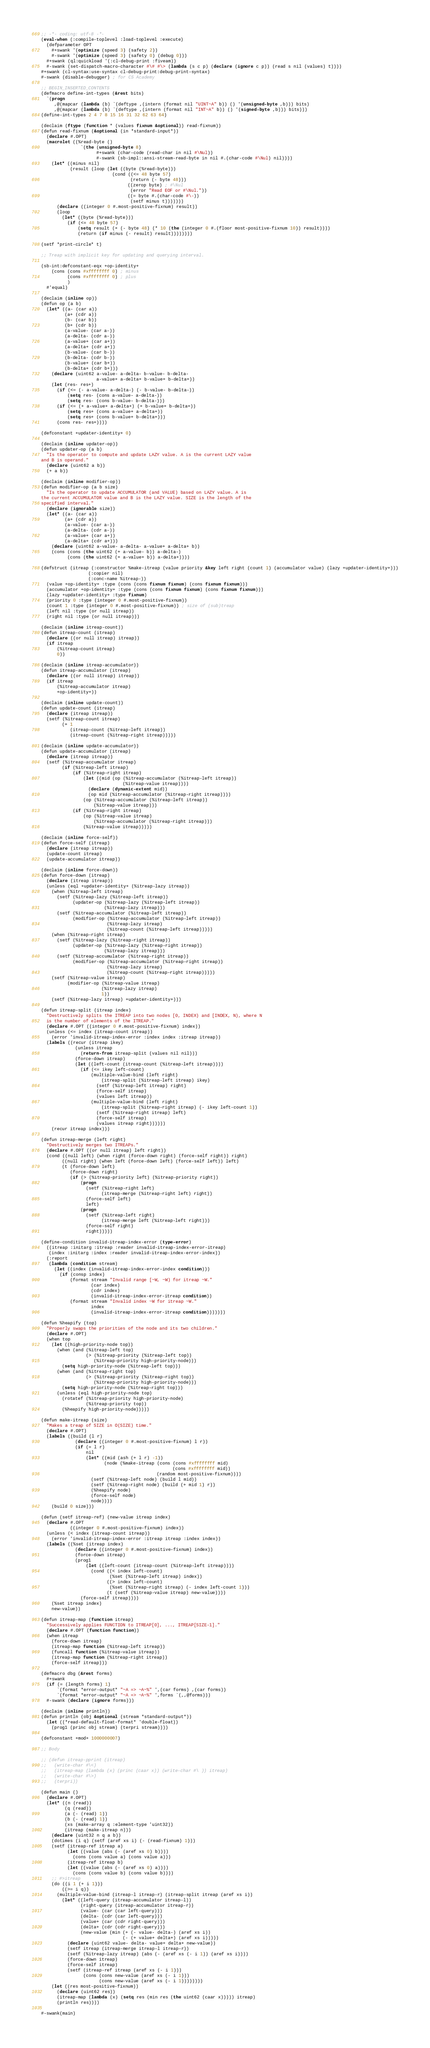Convert code to text. <code><loc_0><loc_0><loc_500><loc_500><_Lisp_>;; -*- coding: utf-8 -*-
(eval-when (:compile-toplevel :load-toplevel :execute)
  (defparameter OPT
    #+swank '(optimize (speed 3) (safety 2))
    #-swank '(optimize (speed 3) (safety 0) (debug 0)))
  #+swank (ql:quickload '(:cl-debug-print :fiveam))
  #-swank (set-dispatch-macro-character #\# #\> (lambda (s c p) (declare (ignore c p)) (read s nil (values) t))))
#+swank (cl-syntax:use-syntax cl-debug-print:debug-print-syntax)
#-swank (disable-debugger) ; for CS Academy

;; BEGIN_INSERTED_CONTENTS
(defmacro define-int-types (&rest bits)
  `(progn
     ,@(mapcar (lambda (b) `(deftype ,(intern (format nil "UINT~A" b)) () '(unsigned-byte ,b))) bits)
     ,@(mapcar (lambda (b) `(deftype ,(intern (format nil "INT~A" b)) () '(signed-byte ,b))) bits)))
(define-int-types 2 4 7 8 15 16 31 32 62 63 64)

(declaim (ftype (function * (values fixnum &optional)) read-fixnum))
(defun read-fixnum (&optional (in *standard-input*))
  (declare #.OPT)
  (macrolet ((%read-byte ()
               `(the (unsigned-byte 8)
                     #+swank (char-code (read-char in nil #\Nul))
                     #-swank (sb-impl::ansi-stream-read-byte in nil #.(char-code #\Nul) nil))))
    (let* ((minus nil)
           (result (loop (let ((byte (%read-byte)))
                           (cond ((<= 48 byte 57)
                                  (return (- byte 48)))
                                 ((zerop byte) ; #\Nul
                                  (error "Read EOF or #\Nul."))
                                 ((= byte #.(char-code #\-))
                                  (setf minus t)))))))
      (declare ((integer 0 #.most-positive-fixnum) result))
      (loop
        (let* ((byte (%read-byte)))
          (if (<= 48 byte 57)
              (setq result (+ (- byte 48) (* 10 (the (integer 0 #.(floor most-positive-fixnum 10)) result))))
              (return (if minus (- result) result))))))))

(setf *print-circle* t)

;; Treap with implicit key for updating and querying interval.

(sb-int:defconstant-eqx +op-identity+
    (cons (cons #xffffffff 0) ; minus
          (cons #xffffffff 0) ; plus
          )
  #'equal)

(declaim (inline op))
(defun op (a b)
  (let* ((a- (car a))
         (a+ (cdr a))
         (b- (car b))
         (b+ (cdr b))
         (a-value- (car a-))
         (a-delta- (cdr a-))
         (a-value+ (car a+))
         (a-delta+ (cdr a+))
         (b-value- (car b-))
         (b-delta- (cdr b-))
         (b-value+ (car b+))
         (b-delta+ (cdr b+)))
    (declare (uint62 a-value- a-delta- b-value- b-delta-
                     a-value+ a-delta+ b-value+ b-delta+))
    (let (res- res+)
      (if (<= (- a-value- a-delta-) (- b-value- b-delta-))
          (setq res- (cons a-value- a-delta-))
          (setq res- (cons b-value- b-delta-)))
      (if (<= (+ a-value+ a-delta+) (+ b-value+ b-delta+))
          (setq res+ (cons a-value+ a-delta+))
          (setq res+ (cons b-value+ b-delta+)))
      (cons res- res+))))

(defconstant +updater-identity+ 0)

(declaim (inline updater-op))
(defun updater-op (a b)
  "Is the operator to compute and update LAZY value. A is the current LAZY value
and B is operand."
  (declare (uint62 a b))
  (+ a b))

(declaim (inline modifier-op))
(defun modifier-op (a b size)
  "Is the operator to update ACCUMULATOR (and VALUE) based on LAZY value. A is
the current ACCUMULATOR value and B is the LAZY value. SIZE is the length of the
specified interval."
  (declare (ignorable size))
  (let* ((a- (car a))
         (a+ (cdr a))
         (a-value- (car a-))
         (a-delta- (cdr a-))
         (a-value+ (car a+))
         (a-delta+ (cdr a+)))
    (declare (uint62 a-value- a-delta- a-value+ a-delta+ b))
    (cons (cons (the uint62 (+ a-value- b)) a-delta-)
          (cons (the uint62 (+ a-value+ b)) a-delta+))))

(defstruct (itreap (:constructor %make-itreap (value priority &key left right (count 1) (accumulator value) (lazy +updater-identity+)))
                  (:copier nil)
                  (:conc-name %itreap-))
  (value +op-identity+ :type (cons (cons fixnum fixnum) (cons fixnum fixnum)))
  (accumulator +op-identity+ :type (cons (cons fixnum fixnum) (cons fixnum fixnum)))
  (lazy +updater-identity+ :type fixnum)
  (priority 0 :type (integer 0 #.most-positive-fixnum))
  (count 1 :type (integer 0 #.most-positive-fixnum)) ; size of (sub)treap
  (left nil :type (or null itreap))
  (right nil :type (or null itreap)))

(declaim (inline itreap-count))
(defun itreap-count (itreap)
  (declare ((or null itreap) itreap))
  (if itreap
      (%itreap-count itreap)
      0))

(declaim (inline itreap-accumulator))
(defun itreap-accumulator (itreap)
  (declare ((or null itreap) itreap))
  (if itreap
      (%itreap-accumulator itreap)
      +op-identity+))

(declaim (inline update-count))
(defun update-count (itreap)
  (declare (itreap itreap))
  (setf (%itreap-count itreap)
        (+ 1
           (itreap-count (%itreap-left itreap))
           (itreap-count (%itreap-right itreap)))))

(declaim (inline update-accumulator))
(defun update-accumulator (itreap)
  (declare (itreap itreap))
  (setf (%itreap-accumulator itreap)
        (if (%itreap-left itreap)
            (if (%itreap-right itreap)
                (let ((mid (op (%itreap-accumulator (%itreap-left itreap))
                               (%itreap-value itreap))))
                  (declare (dynamic-extent mid))
                  (op mid (%itreap-accumulator (%itreap-right itreap))))
                (op (%itreap-accumulator (%itreap-left itreap))
                    (%itreap-value itreap)))
            (if (%itreap-right itreap)
                (op (%itreap-value itreap)
                    (%itreap-accumulator (%itreap-right itreap)))
                (%itreap-value itreap)))))

(declaim (inline force-self))
(defun force-self (itreap)
  (declare (itreap itreap))
  (update-count itreap)
  (update-accumulator itreap))

(declaim (inline force-down))
(defun force-down (itreap)
  (declare (itreap itreap))
  (unless (eql +updater-identity+ (%itreap-lazy itreap))
    (when (%itreap-left itreap)
      (setf (%itreap-lazy (%itreap-left itreap))
            (updater-op (%itreap-lazy (%itreap-left itreap))
                        (%itreap-lazy itreap)))
      (setf (%itreap-accumulator (%itreap-left itreap))
            (modifier-op (%itreap-accumulator (%itreap-left itreap))
                         (%itreap-lazy itreap)
                         (%itreap-count (%itreap-left itreap)))))
    (when (%itreap-right itreap)
      (setf (%itreap-lazy (%itreap-right itreap))
            (updater-op (%itreap-lazy (%itreap-right itreap))
                        (%itreap-lazy itreap)))
      (setf (%itreap-accumulator (%itreap-right itreap))
            (modifier-op (%itreap-accumulator (%itreap-right itreap))
                         (%itreap-lazy itreap)
                         (%itreap-count (%itreap-right itreap)))))
    (setf (%itreap-value itreap)
          (modifier-op (%itreap-value itreap)
                       (%itreap-lazy itreap)
                       1))
    (setf (%itreap-lazy itreap) +updater-identity+)))

(defun itreap-split (itreap index)
  "Destructively splits the ITREAP into two nodes [0, INDEX) and [INDEX, N), where N
  is the number of elements of the ITREAP."
  (declare #.OPT ((integer 0 #.most-positive-fixnum) index))
  (unless (<= index (itreap-count itreap))
    (error 'invalid-itreap-index-error :index index :itreap itreap))
  (labels ((recur (itreap ikey)
             (unless itreap
               (return-from itreap-split (values nil nil)))
             (force-down itreap)
             (let ((left-count (itreap-count (%itreap-left itreap))))
               (if (<= ikey left-count)
                   (multiple-value-bind (left right)
                       (itreap-split (%itreap-left itreap) ikey)
                     (setf (%itreap-left itreap) right)
                     (force-self itreap)
                     (values left itreap))
                   (multiple-value-bind (left right)
                       (itreap-split (%itreap-right itreap) (- ikey left-count 1))
                     (setf (%itreap-right itreap) left)
                     (force-self itreap)
                     (values itreap right))))))
    (recur itreap index)))

(defun itreap-merge (left right)
  "Destructively merges two ITREAPs."
  (declare #.OPT ((or null itreap) left right))
  (cond ((null left) (when right (force-down right) (force-self right)) right)
        ((null right) (when left (force-down left) (force-self left)) left)
        (t (force-down left)
           (force-down right)
           (if (> (%itreap-priority left) (%itreap-priority right))
               (progn
                 (setf (%itreap-right left)
                       (itreap-merge (%itreap-right left) right))
                 (force-self left)
                 left)
               (progn
                 (setf (%itreap-left right)
                       (itreap-merge left (%itreap-left right)))
                 (force-self right)
                 right)))))

(define-condition invalid-itreap-index-error (type-error)
  ((itreap :initarg :itreap :reader invalid-itreap-index-error-itreap)
   (index :initarg :index :reader invalid-itreap-index-error-index))
  (:report
   (lambda (condition stream)
     (let ((index (invalid-itreap-index-error-index condition)))
       (if (consp index)
           (format stream "Invalid range [~W, ~W) for itreap ~W."
                   (car index)
                   (cdr index)
                   (invalid-itreap-index-error-itreap condition))
           (format stream "Invalid index ~W for itreap ~W."
                   index
                   (invalid-itreap-index-error-itreap condition)))))))

(defun %heapify (top)
  "Properly swaps the priorities of the node and its two children."
  (declare #.OPT)
  (when top
    (let ((high-priority-node top))
      (when (and (%itreap-left top)
                 (> (%itreap-priority (%itreap-left top))
                    (%itreap-priority high-priority-node)))
        (setq high-priority-node (%itreap-left top)))
      (when (and (%itreap-right top)
                 (> (%itreap-priority (%itreap-right top))
                    (%itreap-priority high-priority-node)))
        (setq high-priority-node (%itreap-right top)))
      (unless (eql high-priority-node top)
        (rotatef (%itreap-priority high-priority-node)
                 (%itreap-priority top))
        (%heapify high-priority-node)))))

(defun make-itreap (size)
  "Makes a treap of SIZE in O(SIZE) time."
  (declare #.OPT)
  (labels ((build (l r)
             (declare ((integer 0 #.most-positive-fixnum) l r))
             (if (= l r)
                 nil
                 (let* ((mid (ash (+ l r) -1))
                        (node (%make-itreap (cons (cons #xffffffff mid)
                                                  (cons #xffffffff mid))
                                            (random most-positive-fixnum))))
                   (setf (%itreap-left node) (build l mid))
                   (setf (%itreap-right node) (build (+ mid 1) r))
                   (%heapify node)
                   (force-self node)
                   node))))
    (build 0 size)))

(defun (setf itreap-ref) (new-value itreap index)
  (declare #.OPT
           ((integer 0 #.most-positive-fixnum) index))
  (unless (< index (itreap-count itreap))
    (error 'invalid-itreap-index-error :itreap itreap :index index))
  (labels ((%set (itreap index)
             (declare ((integer 0 #.most-positive-fixnum) index))
             (force-down itreap)
             (prog1
                 (let ((left-count (itreap-count (%itreap-left itreap))))
                   (cond ((< index left-count)
                          (%set (%itreap-left itreap) index))
                         ((> index left-count)
                          (%set (%itreap-right itreap) (- index left-count 1)))
                         (t (setf (%itreap-value itreap) new-value))))
               (force-self itreap))))
    (%set itreap index)
    new-value))

(defun itreap-map (function itreap)
  "Successively applies FUNCTION to ITREAP[0], ..., ITREAP[SIZE-1]."
  (declare #.OPT (function function))
  (when itreap
    (force-down itreap)
    (itreap-map function (%itreap-left itreap))
    (funcall function (%itreap-value itreap))
    (itreap-map function (%itreap-right itreap))
    (force-self itreap)))

(defmacro dbg (&rest forms)
  #+swank
  (if (= (length forms) 1)
      `(format *error-output* "~A => ~A~%" ',(car forms) ,(car forms))
      `(format *error-output* "~A => ~A~%" ',forms `(,,@forms)))
  #-swank (declare (ignore forms)))

(declaim (inline println))
(defun println (obj &optional (stream *standard-output*))
  (let ((*read-default-float-format* 'double-float))
    (prog1 (princ obj stream) (terpri stream))))

(defconstant +mod+ 1000000007)

;; Body

;; (defun itreap-pprint (itreap)
;;   (write-char #\<)
;;   (itreap-map (lambda (x) (princ (caar x)) (write-char #\ )) itreap)
;;   (write-char #\>)
;;   (terpri))

(defun main ()
  (declare #.OPT)
  (let* ((n (read))
         (q (read))
         (a (- (read) 1))
         (b (- (read) 1))
         (xs (make-array q :element-type 'uint32))
         (itreap (make-itreap n)))
    (declare (uint32 n q a b))
    (dotimes (i q) (setf (aref xs i) (- (read-fixnum) 1)))
    (setf (itreap-ref itreap a)
          (let ((value (abs (- (aref xs 0) b))))
            (cons (cons value a) (cons value a)))
          (itreap-ref itreap b)
          (let ((value (abs (- (aref xs 0) a))))
            (cons (cons value b) (cons value b))))
    ;; #>itreap
    (do ((i 1 (+ i 1)))
        ((>= i q))
      (multiple-value-bind (itreap-l itreap-r) (itreap-split itreap (aref xs i))
        (let* ((left-query (itreap-accumulator itreap-l))
               (right-query (itreap-accumulator itreap-r))
               (value- (car (car left-query)))
               (delta- (cdr (car left-query)))
               (value+ (car (cdr right-query)))
               (delta+ (cdr (cdr right-query)))
               (new-value (min (+ (- value- delta-) (aref xs i))
                               (- (+ value+ delta+) (aref xs i)))))
          (declare (uint62 value- delta- value+ delta+ new-value))
          (setf itreap (itreap-merge itreap-l itreap-r))
          (setf (%itreap-lazy itreap) (abs (- (aref xs (- i 1)) (aref xs i))))
          (force-down itreap)
          (force-self itreap)
          (setf (itreap-ref itreap (aref xs (- i 1)))
                (cons (cons new-value (aref xs (- i 1)))
                      (cons new-value (aref xs (- i 1))))))))
    (let ((res most-positive-fixnum))
      (declare (uint62 res))
      (itreap-map (lambda (x) (setq res (min res (the uint62 (caar x))))) itreap)
      (println res))))

#-swank(main)
</code> 